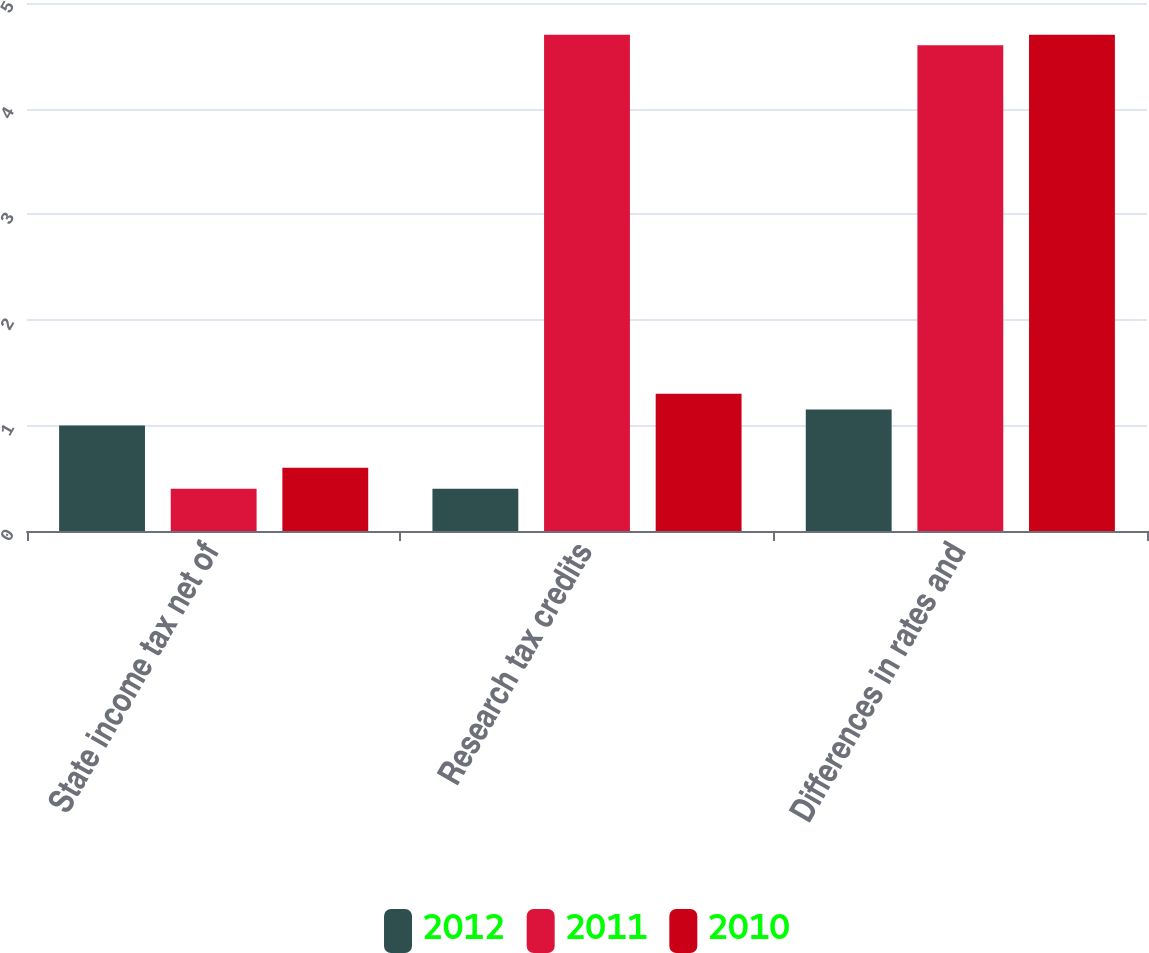Convert chart to OTSL. <chart><loc_0><loc_0><loc_500><loc_500><stacked_bar_chart><ecel><fcel>State income tax net of<fcel>Research tax credits<fcel>Differences in rates and<nl><fcel>2012<fcel>1<fcel>0.4<fcel>1.15<nl><fcel>2011<fcel>0.4<fcel>4.7<fcel>4.6<nl><fcel>2010<fcel>0.6<fcel>1.3<fcel>4.7<nl></chart> 